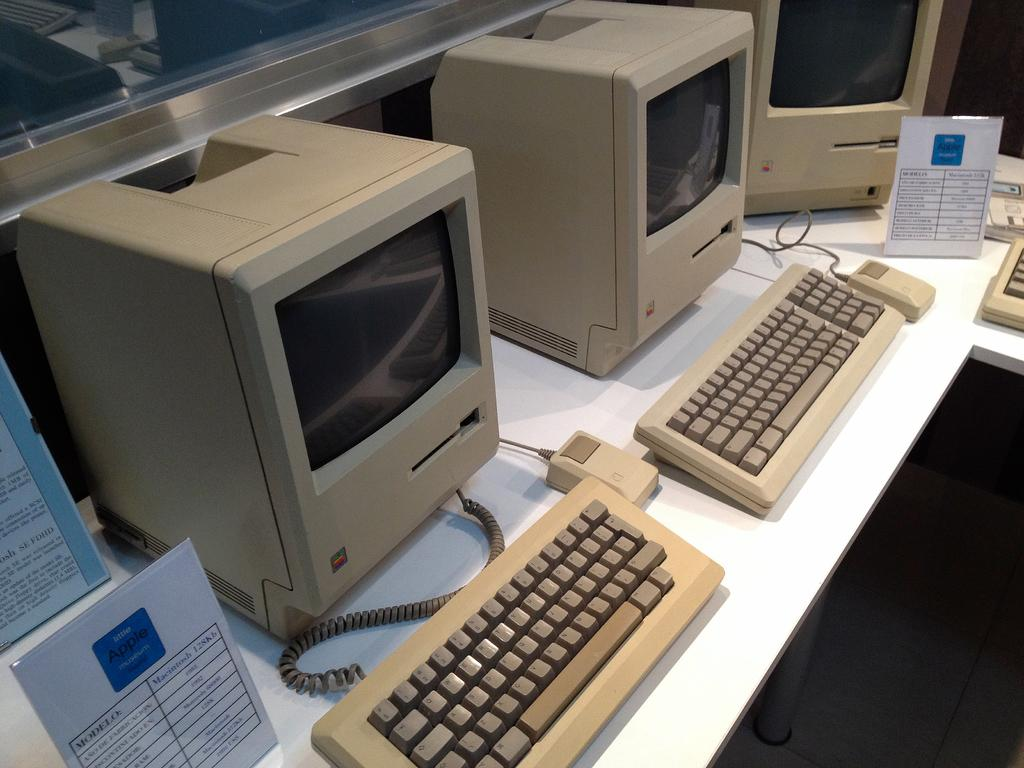<image>
Summarize the visual content of the image. Old desktop next to a sign taht says Macintosh 128kb. 